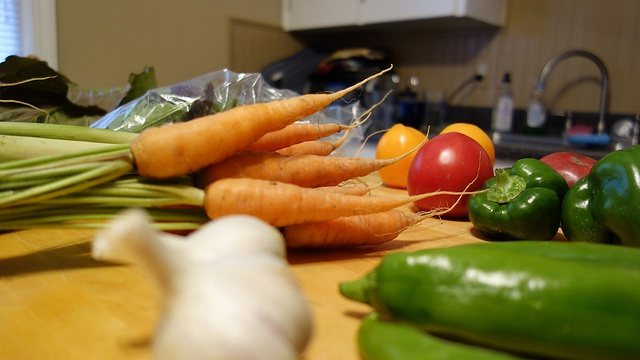Describe the objects in this image and their specific colors. I can see dining table in lightblue, orange, maroon, and olive tones, carrot in lightblue, tan, red, and orange tones, carrot in lightblue, orange, and red tones, carrot in lightblue, red, maroon, and tan tones, and carrot in lightblue, maroon, and red tones in this image. 